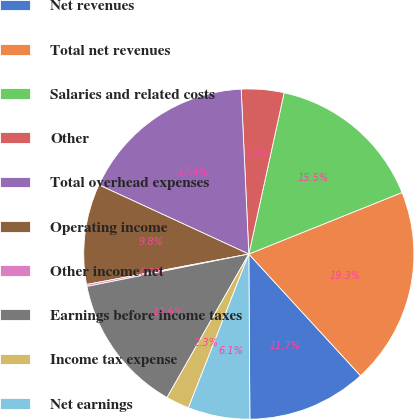<chart> <loc_0><loc_0><loc_500><loc_500><pie_chart><fcel>Net revenues<fcel>Total net revenues<fcel>Salaries and related costs<fcel>Other<fcel>Total overhead expenses<fcel>Operating income<fcel>Other income net<fcel>Earnings before income taxes<fcel>Income tax expense<fcel>Net earnings<nl><fcel>11.72%<fcel>19.26%<fcel>15.49%<fcel>4.17%<fcel>17.38%<fcel>9.83%<fcel>0.19%<fcel>13.61%<fcel>2.29%<fcel>6.06%<nl></chart> 